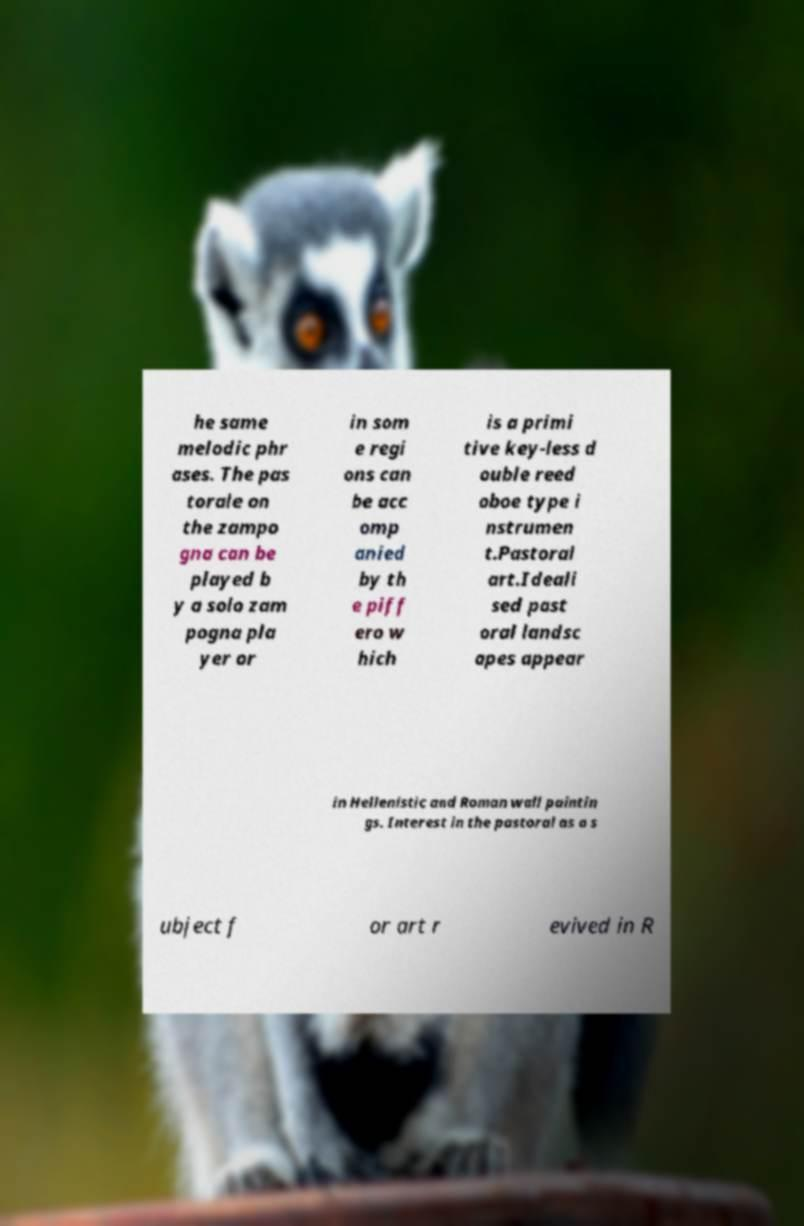What messages or text are displayed in this image? I need them in a readable, typed format. he same melodic phr ases. The pas torale on the zampo gna can be played b y a solo zam pogna pla yer or in som e regi ons can be acc omp anied by th e piff ero w hich is a primi tive key-less d ouble reed oboe type i nstrumen t.Pastoral art.Ideali sed past oral landsc apes appear in Hellenistic and Roman wall paintin gs. Interest in the pastoral as a s ubject f or art r evived in R 